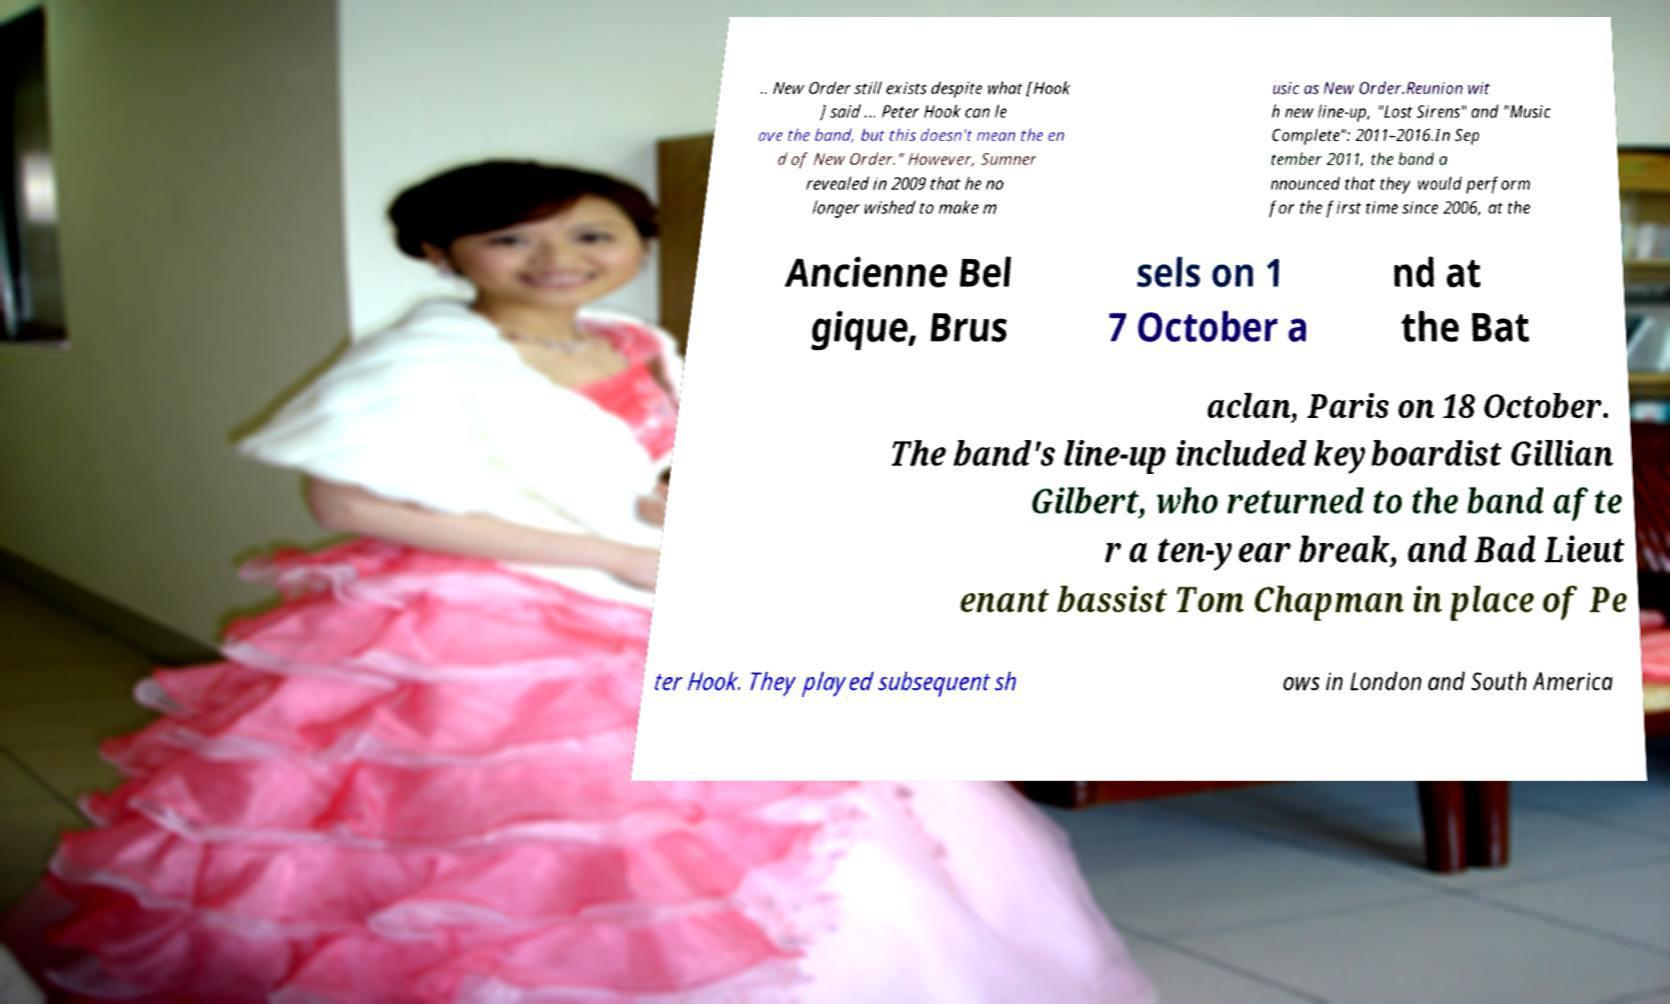Please read and relay the text visible in this image. What does it say? .. New Order still exists despite what [Hook ] said ... Peter Hook can le ave the band, but this doesn't mean the en d of New Order." However, Sumner revealed in 2009 that he no longer wished to make m usic as New Order.Reunion wit h new line-up, "Lost Sirens" and "Music Complete": 2011–2016.In Sep tember 2011, the band a nnounced that they would perform for the first time since 2006, at the Ancienne Bel gique, Brus sels on 1 7 October a nd at the Bat aclan, Paris on 18 October. The band's line-up included keyboardist Gillian Gilbert, who returned to the band afte r a ten-year break, and Bad Lieut enant bassist Tom Chapman in place of Pe ter Hook. They played subsequent sh ows in London and South America 